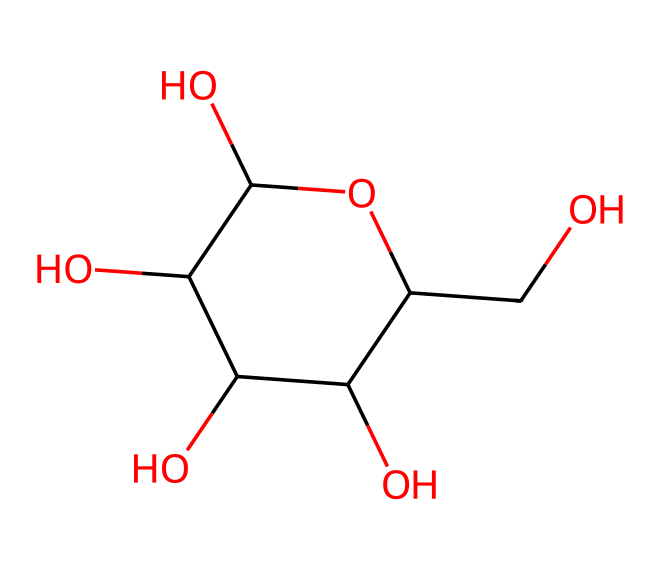What is the total number of carbon atoms in this chemical? By examining the SMILES representation, we can count each 'C' in the structure. In the provided SMILES, there are 6 'C' atoms that can be identified, which represent the total number of carbon atoms.
Answer: 6 How many hydroxyl (OH) groups are present in the molecule? In the given SMILES, we can identify 'O' groups directly bound to hydrogen atoms, which represent hydroxyl groups. Counting these, we find there are 3 hydroxyl groups present in the structure.
Answer: 3 What type of compound is represented by this chemical structure? This chemical structure contains multiple hydroxyl groups, which indicates it is a sugar alcohol. Specifically, the structure resembles that of a carbohydrate due to the multiple -OH functional groups.
Answer: sugar alcohol Which element's presence suggests the functional role of this compound in drug formulation? The presence of multiple -OH (hydroxyl) groups indicates that this compound can serve as a possible excipient that enhances solubility and stability in drug formulations.
Answer: hydroxyl Does this compound contain any rings in its structure? The structure shows a cyclic form because of the presence of mapped spatial connections that form a ring structure, specifically the C1 in the SMILES represents a cyclic arrangement. Thus, there is a ring.
Answer: yes How does the number of hydroxyl groups affect the drug's stability? The multiple hydroxyl groups in this structure can form hydrogen bonds with water, enhancing solubility which can lead to increased stability in aqueous environments, positively impacting the drug's effectiveness.
Answer: enhances stability 